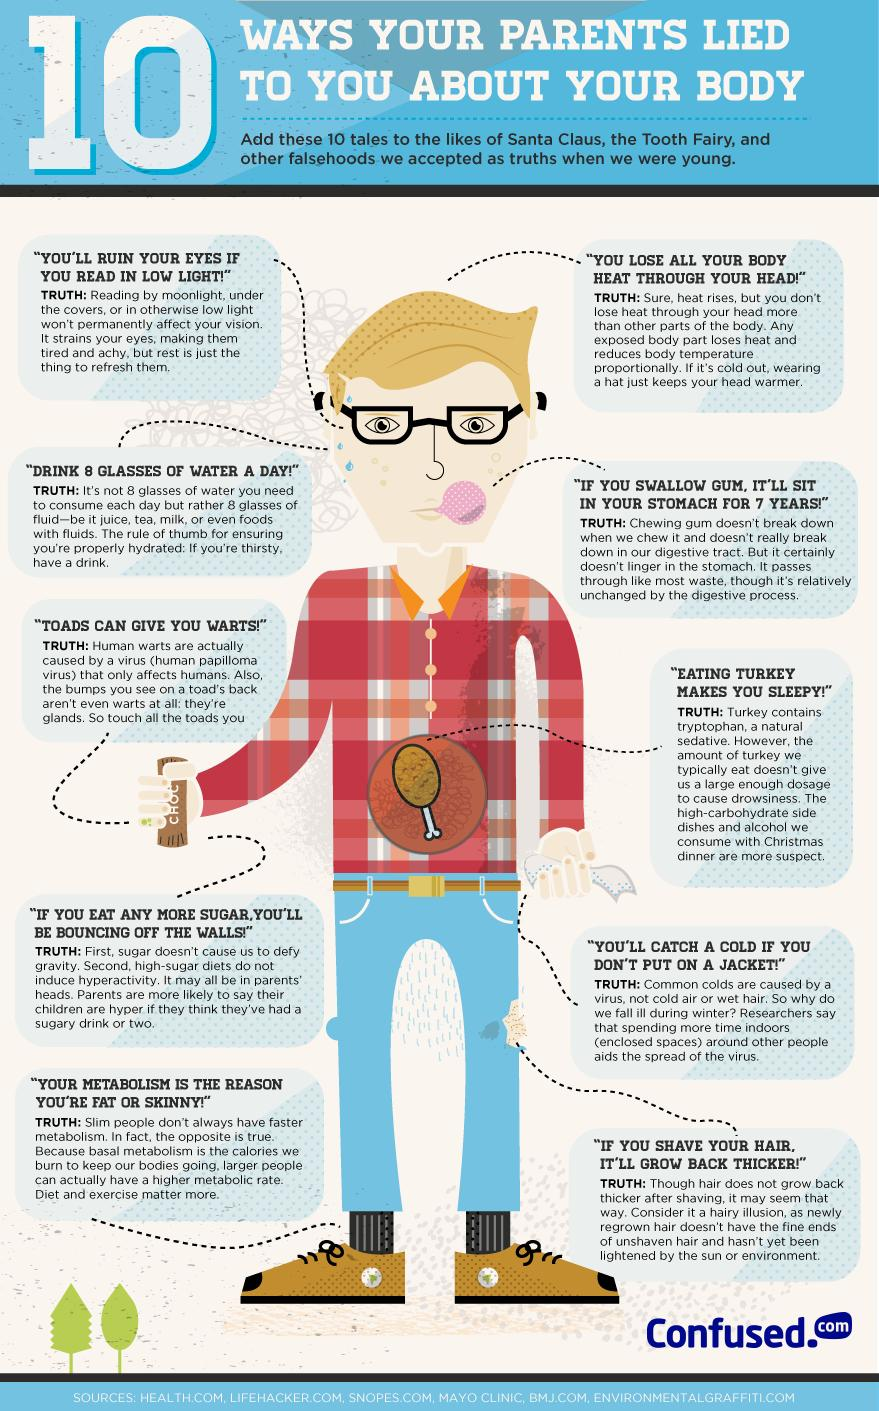List a handful of essential elements in this visual. It is estimated that swallowed gum can become stuck in a person's digestive system and remain there for up to seven years. Reading under low light can lead to eye strain and discomfort, resulting in tired and achy eyes. 